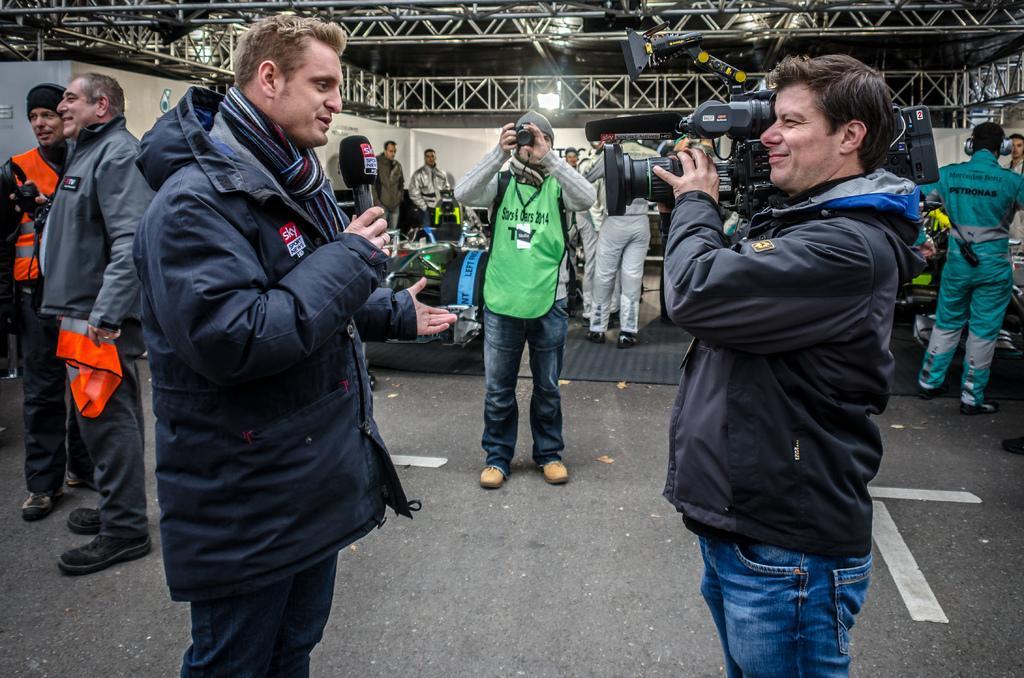Can you describe this image briefly? In this image I can see there is a man standing, he is wearing a jacket and holding a microphone and there are few other people standing and holding cameras. There are few more persons in the backdrop, there are lights attached to the ceiling. 